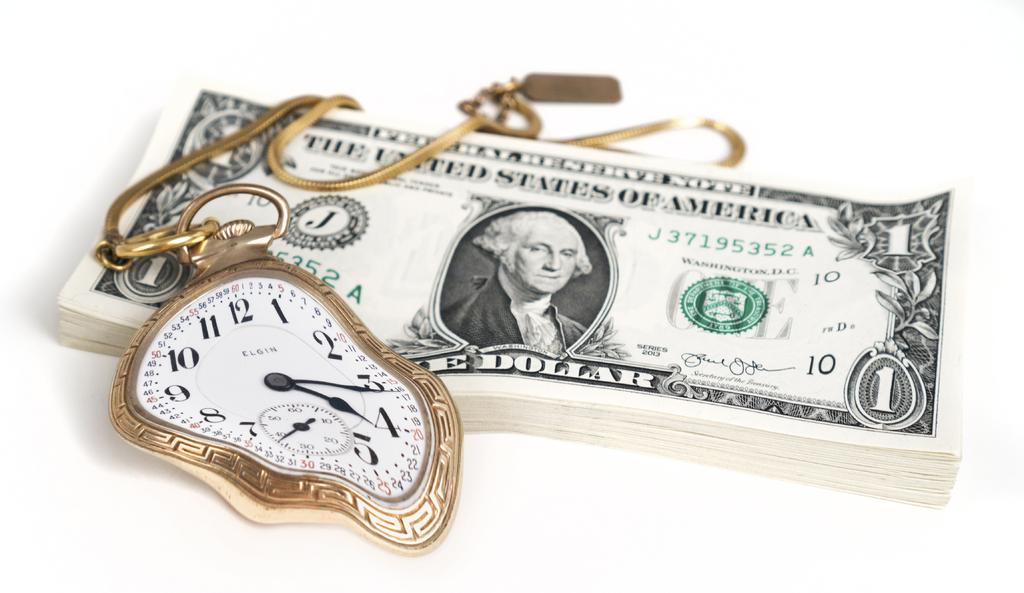What denomination is this money?
Keep it short and to the point. One dollar. What is the serial number on the dollar bill?
Your response must be concise. J37195352a. 